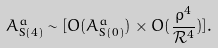<formula> <loc_0><loc_0><loc_500><loc_500>A _ { \text {S} ( 4 ) } ^ { a } \sim [ O ( A _ { \text {S} ( 0 ) } ^ { a } ) \times O ( \frac { \rho ^ { 4 } } { \mathcal { R } ^ { 4 } } ) ] .</formula> 